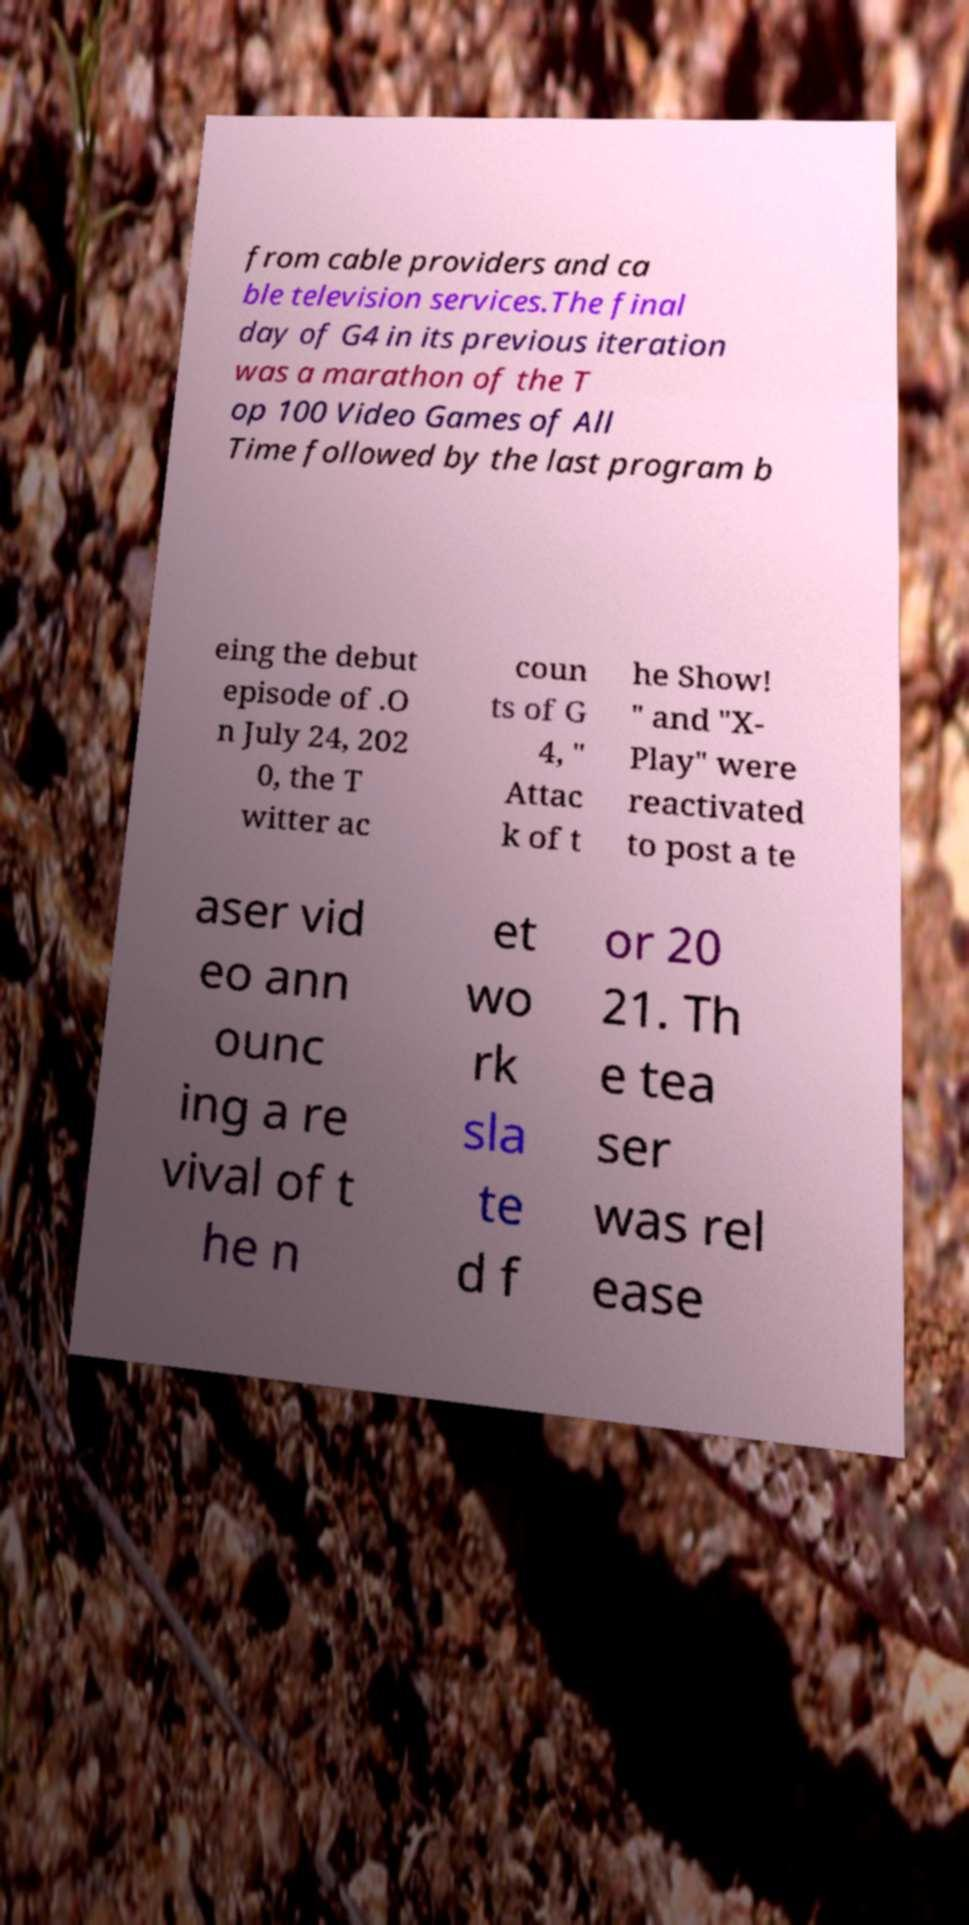What messages or text are displayed in this image? I need them in a readable, typed format. from cable providers and ca ble television services.The final day of G4 in its previous iteration was a marathon of the T op 100 Video Games of All Time followed by the last program b eing the debut episode of .O n July 24, 202 0, the T witter ac coun ts of G 4, " Attac k of t he Show! " and "X- Play" were reactivated to post a te aser vid eo ann ounc ing a re vival of t he n et wo rk sla te d f or 20 21. Th e tea ser was rel ease 